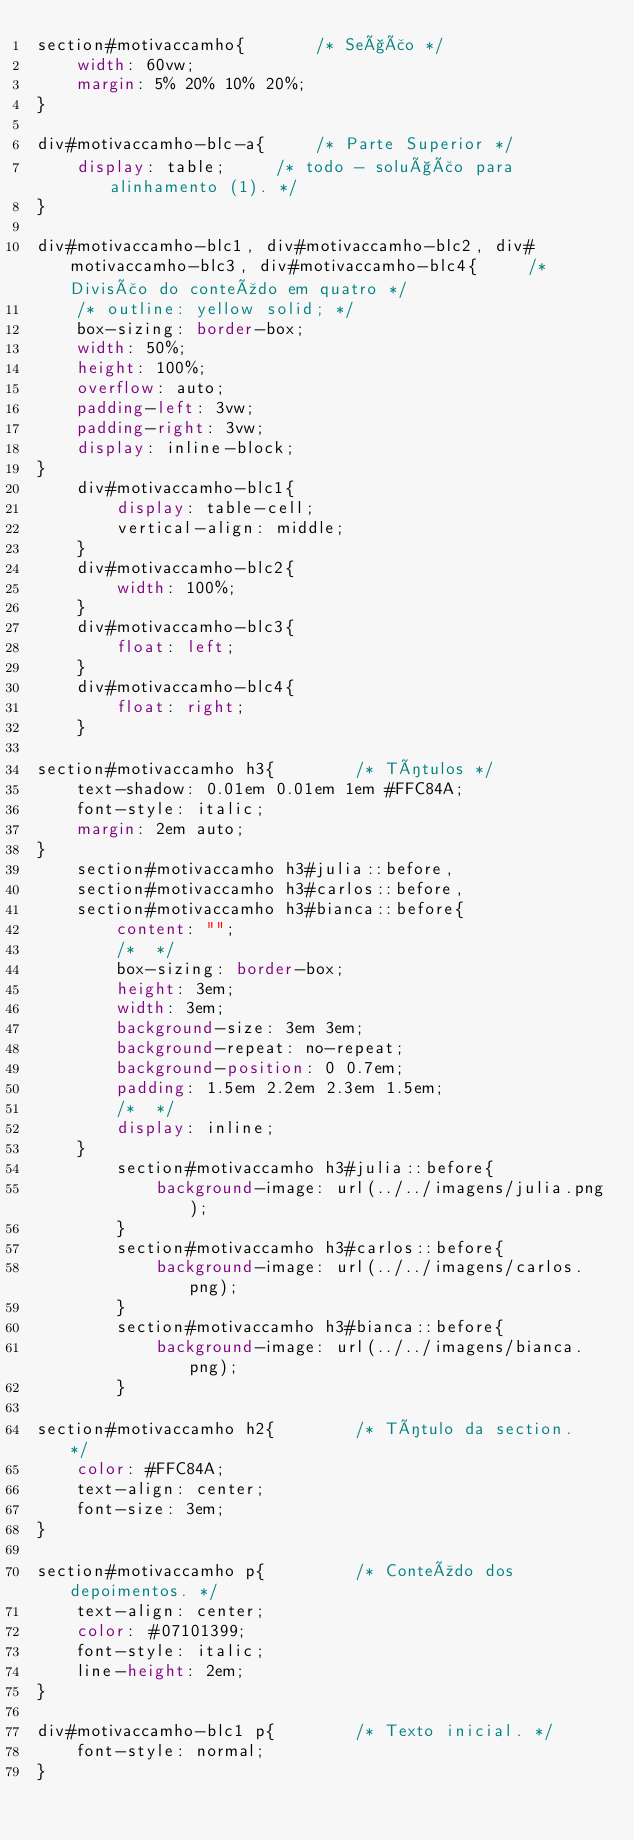<code> <loc_0><loc_0><loc_500><loc_500><_CSS_>section#motivaccamho{       /* Seção */
    width: 60vw;
    margin: 5% 20% 10% 20%;
}

div#motivaccamho-blc-a{     /* Parte Superior */
    display: table;     /* todo - solução para alinhamento (1). */
}

div#motivaccamho-blc1, div#motivaccamho-blc2, div#motivaccamho-blc3, div#motivaccamho-blc4{     /* Divisão do conteúdo em quatro */
    /* outline: yellow solid; */
    box-sizing: border-box;
    width: 50%;
    height: 100%;
    overflow: auto;
    padding-left: 3vw;
    padding-right: 3vw;
    display: inline-block;
}
    div#motivaccamho-blc1{
        display: table-cell;
        vertical-align: middle;
    }
    div#motivaccamho-blc2{
        width: 100%;
    }
    div#motivaccamho-blc3{
        float: left;
    }
    div#motivaccamho-blc4{
        float: right;
    }

section#motivaccamho h3{        /* Títulos */
    text-shadow: 0.01em 0.01em 1em #FFC84A;
    font-style: italic;
    margin: 2em auto;
}
    section#motivaccamho h3#julia::before,
    section#motivaccamho h3#carlos::before,
    section#motivaccamho h3#bianca::before{ 
        content: "";
        /*  */
        box-sizing: border-box;
        height: 3em;
        width: 3em;
        background-size: 3em 3em;
        background-repeat: no-repeat;
        background-position: 0 0.7em;
        padding: 1.5em 2.2em 2.3em 1.5em;
        /*  */
        display: inline;
    }
        section#motivaccamho h3#julia::before{
            background-image: url(../../imagens/julia.png);
        }
        section#motivaccamho h3#carlos::before{ 
            background-image: url(../../imagens/carlos.png);
        }
        section#motivaccamho h3#bianca::before{ 
            background-image: url(../../imagens/bianca.png);
        }

section#motivaccamho h2{        /* Título da section.  */
    color: #FFC84A;
    text-align: center;
    font-size: 3em;
}   

section#motivaccamho p{         /* Conteúdo dos depoimentos. */
    text-align: center;
    color: #07101399;
    font-style: italic;   
    line-height: 2em;
}    

div#motivaccamho-blc1 p{        /* Texto inicial. */
    font-style: normal;
}</code> 